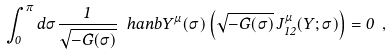Convert formula to latex. <formula><loc_0><loc_0><loc_500><loc_500>\int _ { 0 } ^ { \pi } d \sigma \frac { 1 } { \sqrt { - G ( \sigma ) } } \ h a n b { Y ^ { \mu } ( \sigma ) } \left ( \sqrt { - G ( \sigma ) } \, J _ { 1 2 } ^ { \mu } ( Y ; \sigma ) \right ) = 0 \ ,</formula> 